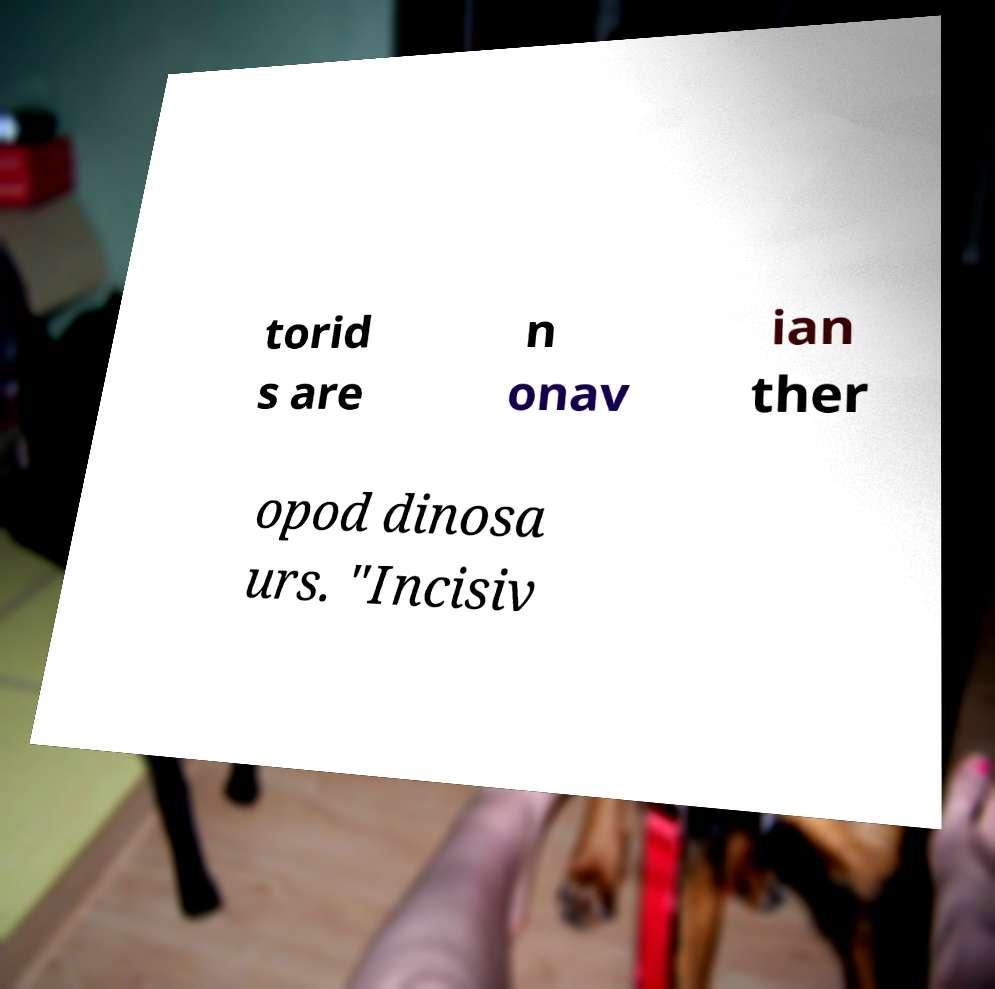Please identify and transcribe the text found in this image. torid s are n onav ian ther opod dinosa urs. "Incisiv 